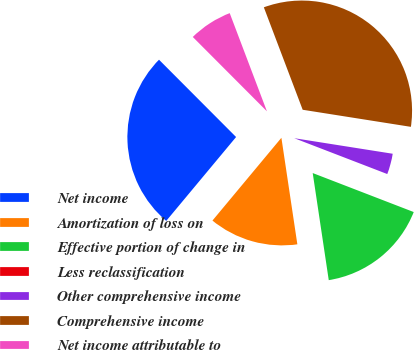Convert chart. <chart><loc_0><loc_0><loc_500><loc_500><pie_chart><fcel>Net income<fcel>Amortization of loss on<fcel>Effective portion of change in<fcel>Less reclassification<fcel>Other comprehensive income<fcel>Comprehensive income<fcel>Net income attributable to<nl><fcel>26.47%<fcel>13.42%<fcel>16.77%<fcel>0.01%<fcel>3.36%<fcel>33.26%<fcel>6.71%<nl></chart> 